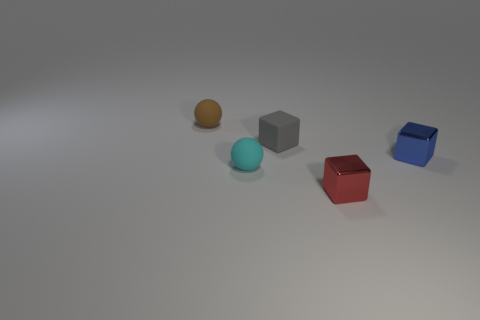Add 3 tiny blue blocks. How many objects exist? 8 Subtract all cubes. How many objects are left? 2 Subtract 0 green spheres. How many objects are left? 5 Subtract all brown matte balls. Subtract all cyan spheres. How many objects are left? 3 Add 1 tiny red things. How many tiny red things are left? 2 Add 5 tiny green blocks. How many tiny green blocks exist? 5 